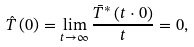Convert formula to latex. <formula><loc_0><loc_0><loc_500><loc_500>\hat { T } \left ( 0 \right ) = \lim _ { t \rightarrow \infty } \frac { \bar { T } ^ { * } \left ( t \cdot 0 \right ) } { t } = 0 ,</formula> 